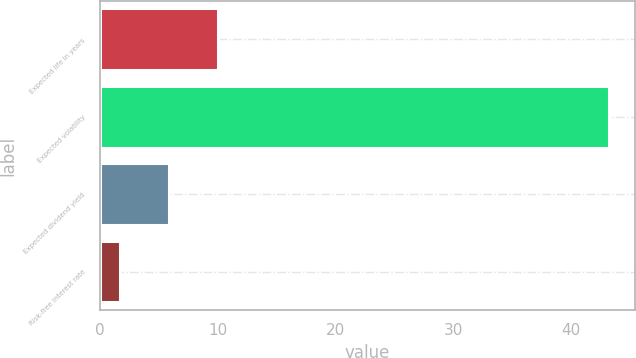Convert chart to OTSL. <chart><loc_0><loc_0><loc_500><loc_500><bar_chart><fcel>Expected life in years<fcel>Expected volatility<fcel>Expected dividend yield<fcel>Risk-free interest rate<nl><fcel>10.04<fcel>43.21<fcel>5.89<fcel>1.74<nl></chart> 